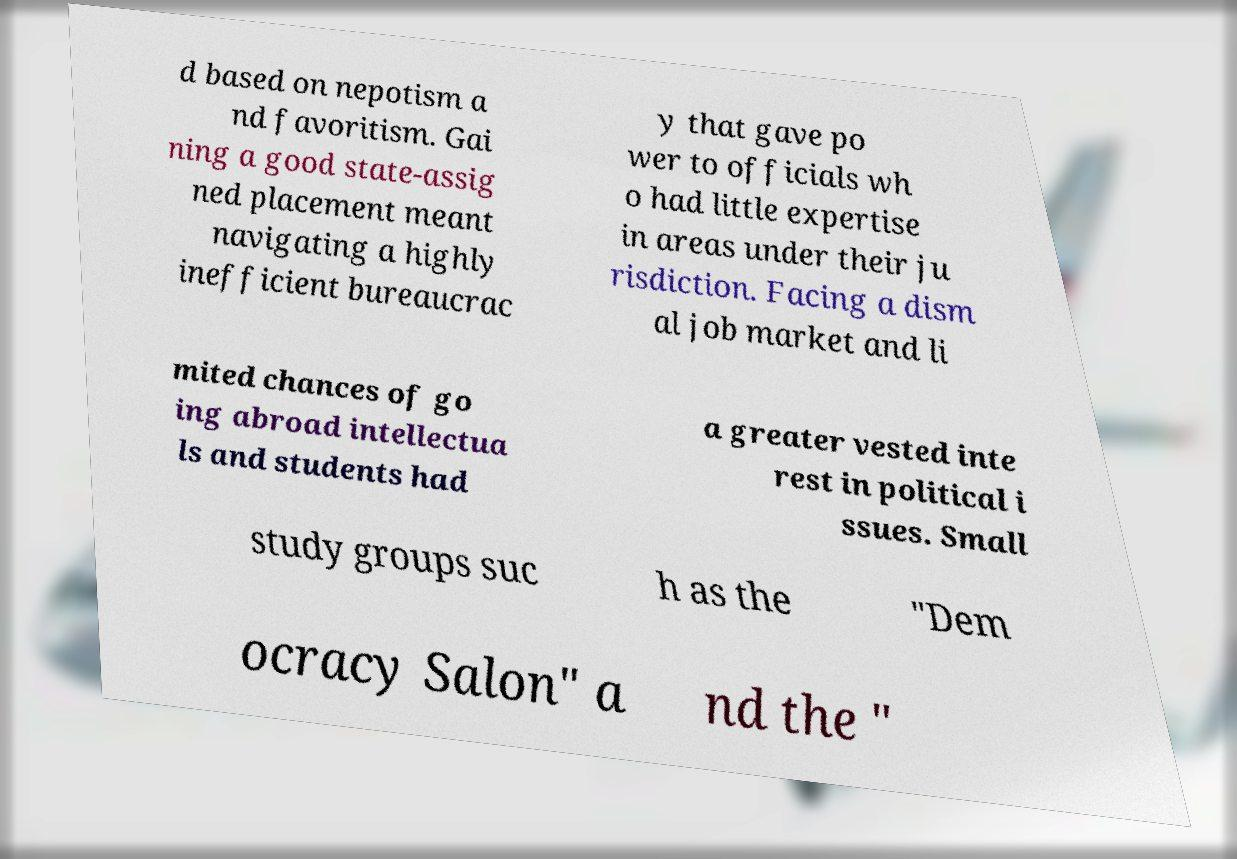What messages or text are displayed in this image? I need them in a readable, typed format. d based on nepotism a nd favoritism. Gai ning a good state-assig ned placement meant navigating a highly inefficient bureaucrac y that gave po wer to officials wh o had little expertise in areas under their ju risdiction. Facing a dism al job market and li mited chances of go ing abroad intellectua ls and students had a greater vested inte rest in political i ssues. Small study groups suc h as the "Dem ocracy Salon" a nd the " 